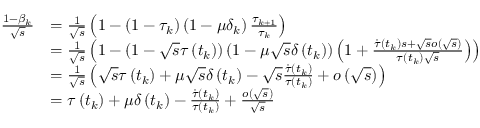<formula> <loc_0><loc_0><loc_500><loc_500>\begin{array} { r l } { \frac { 1 - \beta _ { k } } { \sqrt { s } } } & { = \frac { 1 } { \sqrt { s } } \left ( 1 - \left ( 1 - \tau _ { k } \right ) \left ( 1 - \mu \delta _ { k } \right ) \frac { \tau _ { k + 1 } } { \tau _ { k } } \right ) } \\ & { = \frac { 1 } { \sqrt { s } } \left ( 1 - \left ( 1 - \sqrt { s } \tau \left ( t _ { k } \right ) \right ) \left ( 1 - \mu \sqrt { s } \delta \left ( t _ { k } \right ) \right ) \left ( 1 + \frac { \dot { \tau } \left ( t _ { k } \right ) s + \sqrt { s } o \left ( \sqrt { s } \right ) } { \tau \left ( t _ { k } \right ) \sqrt { s } } \right ) \right ) } \\ & { = \frac { 1 } { \sqrt { s } } \left ( \sqrt { s } \tau \left ( t _ { k } \right ) + \mu \sqrt { s } \delta \left ( t _ { k } \right ) - \sqrt { s } \frac { \dot { \tau } \left ( t _ { k } \right ) } { \tau \left ( t _ { k } \right ) } + o \left ( \sqrt { s } \right ) \right ) } \\ & { = \tau \left ( t _ { k } \right ) + \mu \delta \left ( t _ { k } \right ) - \frac { \dot { \tau } \left ( t _ { k } \right ) } { \tau \left ( t _ { k } \right ) } + \frac { o \left ( \sqrt { s } \right ) } { \sqrt { s } } } \end{array}</formula> 